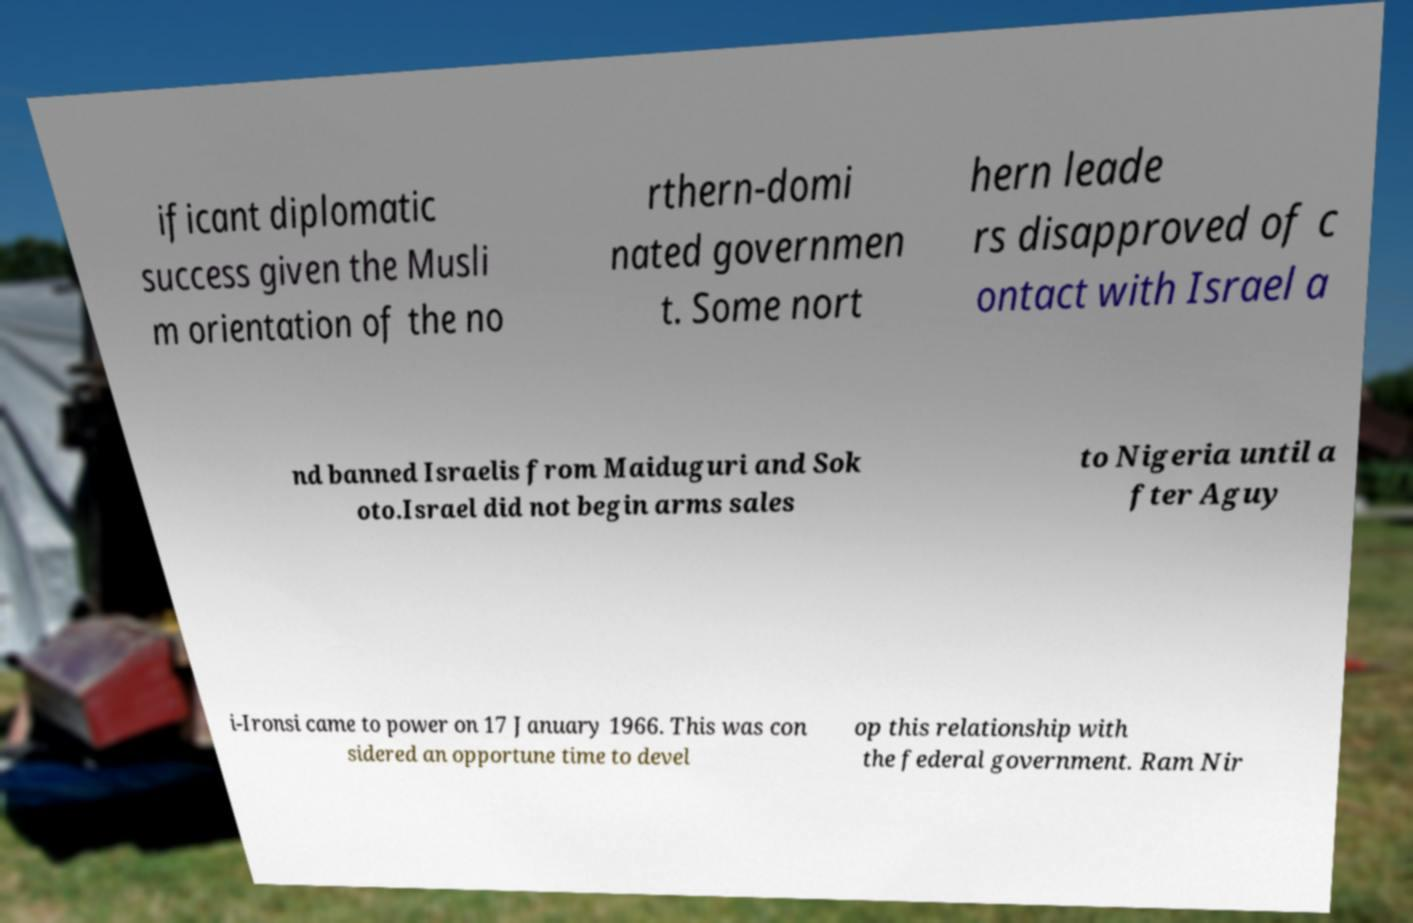For documentation purposes, I need the text within this image transcribed. Could you provide that? ificant diplomatic success given the Musli m orientation of the no rthern-domi nated governmen t. Some nort hern leade rs disapproved of c ontact with Israel a nd banned Israelis from Maiduguri and Sok oto.Israel did not begin arms sales to Nigeria until a fter Aguy i-Ironsi came to power on 17 January 1966. This was con sidered an opportune time to devel op this relationship with the federal government. Ram Nir 